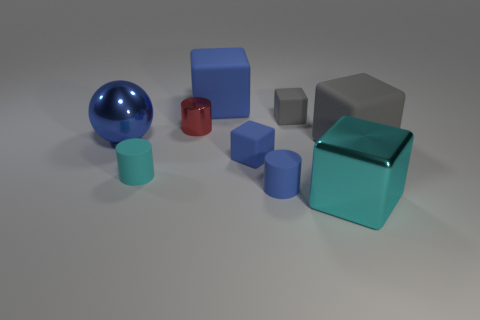Subtract 2 blocks. How many blocks are left? 3 Subtract all large cyan metallic blocks. How many blocks are left? 4 Subtract all cyan blocks. How many blocks are left? 4 Subtract all yellow cubes. Subtract all red cylinders. How many cubes are left? 5 Add 1 cyan rubber cubes. How many objects exist? 10 Subtract all cubes. How many objects are left? 4 Add 5 large blue blocks. How many large blue blocks exist? 6 Subtract 0 purple blocks. How many objects are left? 9 Subtract all large gray matte blocks. Subtract all blue balls. How many objects are left? 7 Add 3 red shiny objects. How many red shiny objects are left? 4 